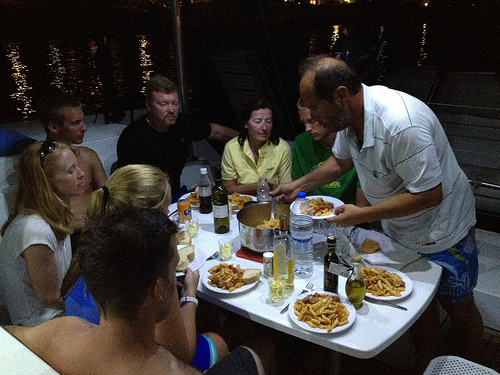Describe the atmosphere of the dining setting captured in the image. The image portrays a casual and warm dining setting on what appears to be a boat, involving a small group of adults engaging in conversation over food and drinks, emphasizing a relaxed social gathering at dusk. 